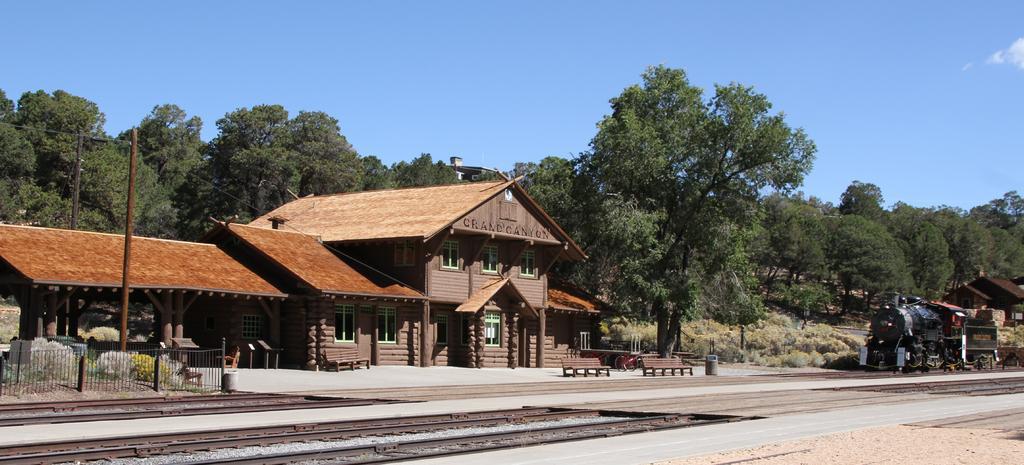Please provide a concise description of this image. In this image there are houses, open-shed, pillars, railing, benches, train engine, trees, poles, plants, train tracks, sky and objects.   